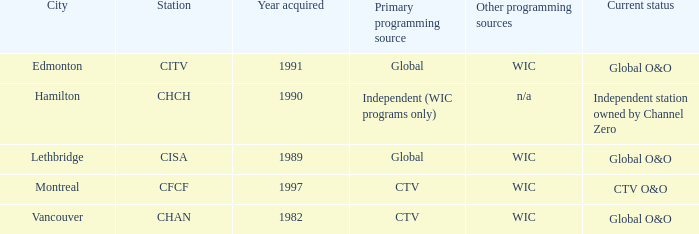Write the full table. {'header': ['City', 'Station', 'Year acquired', 'Primary programming source', 'Other programming sources', 'Current status'], 'rows': [['Edmonton', 'CITV', '1991', 'Global', 'WIC', 'Global O&O'], ['Hamilton', 'CHCH', '1990', 'Independent (WIC programs only)', 'n/a', 'Independent station owned by Channel Zero'], ['Lethbridge', 'CISA', '1989', 'Global', 'WIC', 'Global O&O'], ['Montreal', 'CFCF', '1997', 'CTV', 'WIC', 'CTV O&O'], ['Vancouver', 'CHAN', '1982', 'CTV', 'WIC', 'Global O&O']]} In 1997, how many channels were added? 1.0. 